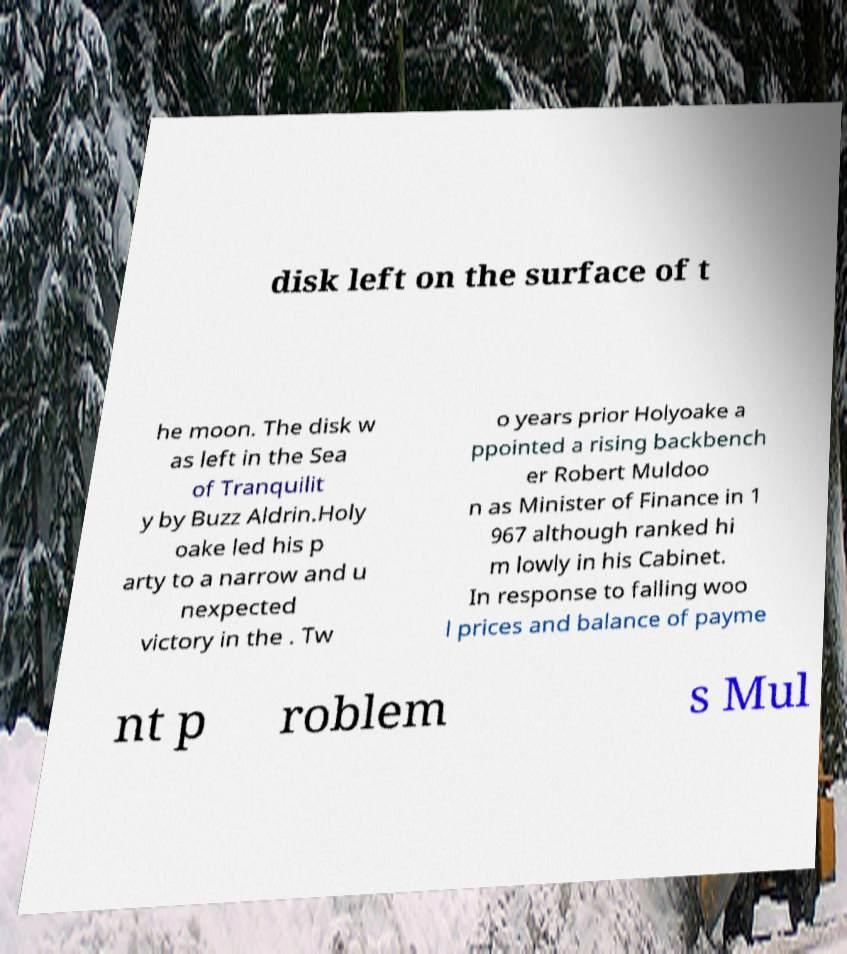What messages or text are displayed in this image? I need them in a readable, typed format. disk left on the surface of t he moon. The disk w as left in the Sea of Tranquilit y by Buzz Aldrin.Holy oake led his p arty to a narrow and u nexpected victory in the . Tw o years prior Holyoake a ppointed a rising backbench er Robert Muldoo n as Minister of Finance in 1 967 although ranked hi m lowly in his Cabinet. In response to falling woo l prices and balance of payme nt p roblem s Mul 